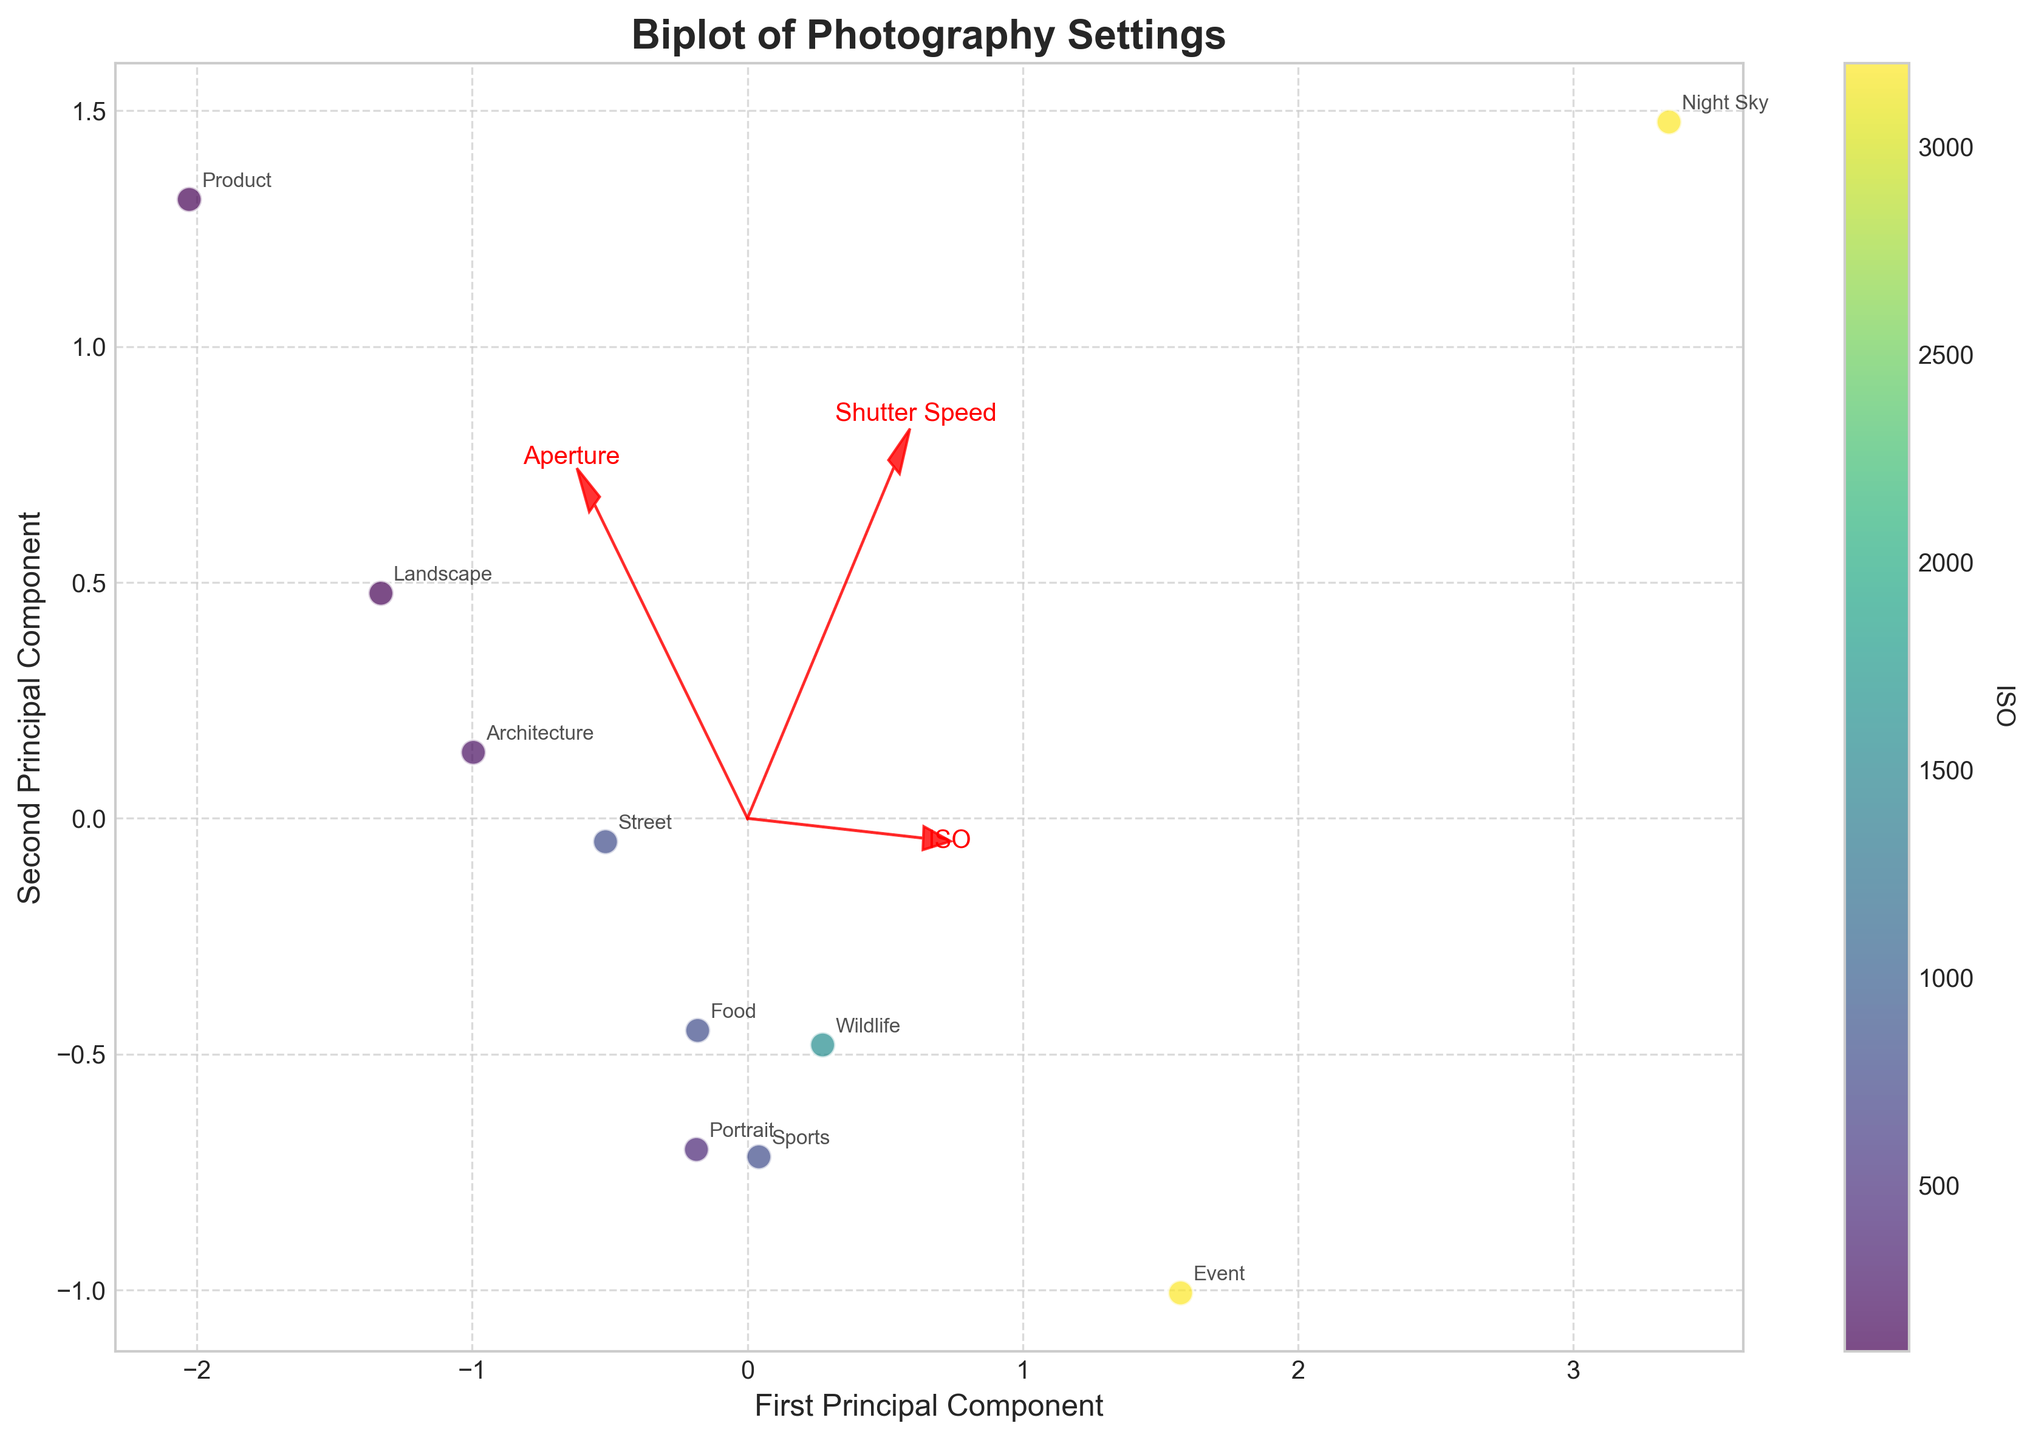What is the title of the plot? The title of the plot is usually found at the top or the bottom of the figure. In this case, it reads "Biplot of Photography Settings".
Answer: Biplot of Photography Settings How many data points are there in the plot? The number of data points can be determined by counting the individual points represented in the plot. Each data point corresponds to a different photography subject.
Answer: 10 What color represents the highest ISO values in the plot? The color representing the highest ISO values can be identified by looking at the colorbar on the right side of the plot. The color shifts towards brighter yellow as ISO values increase.
Answer: Yellow Which direction does the arrow for 'Shutter Speed' point? In a biplot, the arrows indicate the direction and magnitude of the feature vectors. Observing the plot, the arrow labeled 'Shutter Speed' points towards the negative side of the first principal component (left).
Answer: Left Which subjects have ISO values greater than 800? By looking at the color gradients and the colorbar, it is possible to identify subjects with colors close to brighter yellow or within the higher end of the ISO scale: "Event" and "Night Sky".
Answer: Event, Night Sky What is the relative position of the 'Event' subject in the plot? The position of 'Event' can be identified by locating its label on the plot. It is positioned in the lower-left quadrant.
Answer: Lower-left quadrant Which feature has the largest influence on the first principal component? The feature with the largest influence on the first principal component is determined by the length of the arrows from the origin. Observing the plot, the 'Shutter Speed' arrow appears longest along the first principal component.
Answer: Shutter Speed Which two features are most correlated based on the plot? In a biplot, features that point in similar directions are more correlated. Observing the plot, 'Aperture' and 'ISO' point in a similar direction, indicating a higher correlation.
Answer: Aperture and ISO What is the relationship between sports photography and ISO settings based on the plot? By locating 'Sports' photography and noting its color, we can infer its ISO level. 'Sports' is colored in a medium green, corresponding to an ISO level around 800 on the color scale.
Answer: ISO around 800 Which regions of the plot are associated with lower 'Shutter Speed'? Regions where the 'Shutter Speed' arrow is pointing towards indicate lower values. Hence, lower 'Shutter Speed' values are found on the left side of the plot along the first principal component.
Answer: Left side 